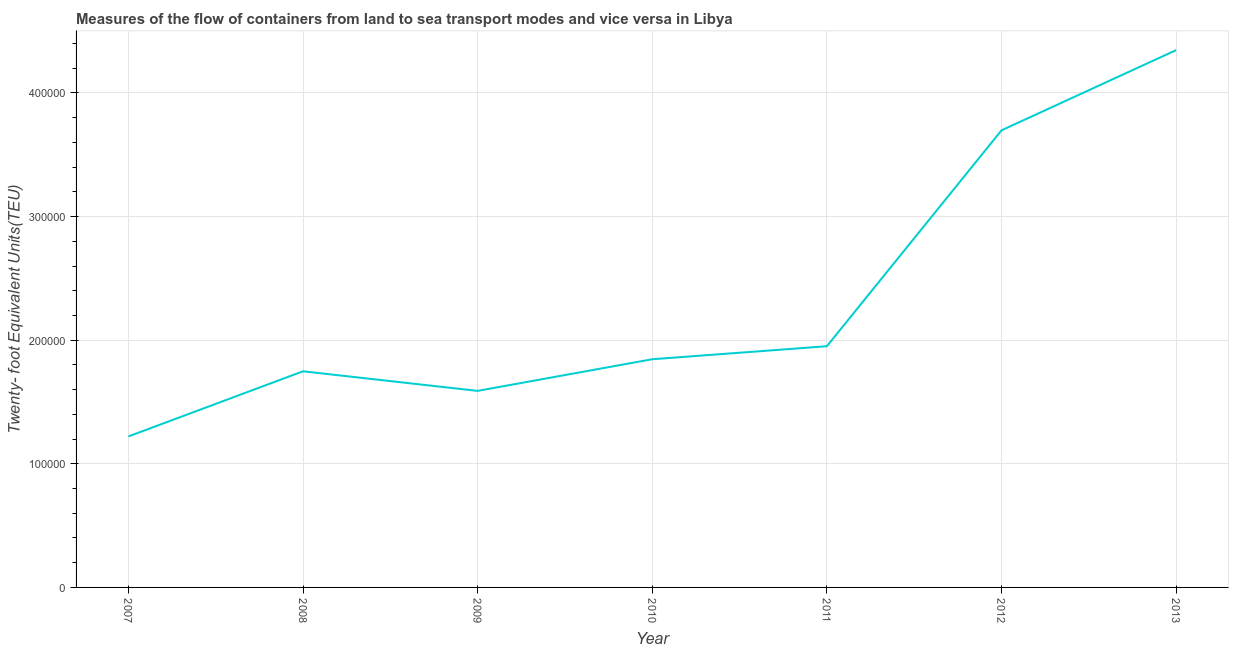What is the container port traffic in 2011?
Provide a short and direct response. 1.95e+05. Across all years, what is the maximum container port traffic?
Keep it short and to the point. 4.35e+05. Across all years, what is the minimum container port traffic?
Your response must be concise. 1.22e+05. In which year was the container port traffic minimum?
Provide a short and direct response. 2007. What is the sum of the container port traffic?
Offer a very short reply. 1.64e+06. What is the difference between the container port traffic in 2008 and 2013?
Make the answer very short. -2.60e+05. What is the average container port traffic per year?
Your answer should be compact. 2.34e+05. What is the median container port traffic?
Give a very brief answer. 1.85e+05. In how many years, is the container port traffic greater than 120000 TEU?
Give a very brief answer. 7. Do a majority of the years between 2009 and 2010 (inclusive) have container port traffic greater than 300000 TEU?
Ensure brevity in your answer.  No. What is the ratio of the container port traffic in 2008 to that in 2013?
Make the answer very short. 0.4. Is the container port traffic in 2008 less than that in 2010?
Offer a very short reply. Yes. Is the difference between the container port traffic in 2010 and 2012 greater than the difference between any two years?
Keep it short and to the point. No. What is the difference between the highest and the second highest container port traffic?
Offer a very short reply. 6.49e+04. What is the difference between the highest and the lowest container port traffic?
Your response must be concise. 3.12e+05. In how many years, is the container port traffic greater than the average container port traffic taken over all years?
Your response must be concise. 2. Does the container port traffic monotonically increase over the years?
Your answer should be compact. No. How many lines are there?
Offer a terse response. 1. What is the difference between two consecutive major ticks on the Y-axis?
Ensure brevity in your answer.  1.00e+05. Does the graph contain grids?
Make the answer very short. Yes. What is the title of the graph?
Offer a very short reply. Measures of the flow of containers from land to sea transport modes and vice versa in Libya. What is the label or title of the Y-axis?
Offer a very short reply. Twenty- foot Equivalent Units(TEU). What is the Twenty- foot Equivalent Units(TEU) of 2007?
Offer a terse response. 1.22e+05. What is the Twenty- foot Equivalent Units(TEU) in 2008?
Your response must be concise. 1.75e+05. What is the Twenty- foot Equivalent Units(TEU) of 2009?
Your response must be concise. 1.59e+05. What is the Twenty- foot Equivalent Units(TEU) in 2010?
Give a very brief answer. 1.85e+05. What is the Twenty- foot Equivalent Units(TEU) in 2011?
Ensure brevity in your answer.  1.95e+05. What is the Twenty- foot Equivalent Units(TEU) of 2012?
Make the answer very short. 3.70e+05. What is the Twenty- foot Equivalent Units(TEU) in 2013?
Give a very brief answer. 4.35e+05. What is the difference between the Twenty- foot Equivalent Units(TEU) in 2007 and 2008?
Your answer should be very brief. -5.27e+04. What is the difference between the Twenty- foot Equivalent Units(TEU) in 2007 and 2009?
Ensure brevity in your answer.  -3.69e+04. What is the difference between the Twenty- foot Equivalent Units(TEU) in 2007 and 2010?
Your answer should be very brief. -6.25e+04. What is the difference between the Twenty- foot Equivalent Units(TEU) in 2007 and 2011?
Offer a terse response. -7.30e+04. What is the difference between the Twenty- foot Equivalent Units(TEU) in 2007 and 2012?
Offer a very short reply. -2.48e+05. What is the difference between the Twenty- foot Equivalent Units(TEU) in 2007 and 2013?
Provide a short and direct response. -3.12e+05. What is the difference between the Twenty- foot Equivalent Units(TEU) in 2008 and 2009?
Ensure brevity in your answer.  1.58e+04. What is the difference between the Twenty- foot Equivalent Units(TEU) in 2008 and 2010?
Offer a very short reply. -9757.69. What is the difference between the Twenty- foot Equivalent Units(TEU) in 2008 and 2011?
Make the answer very short. -2.03e+04. What is the difference between the Twenty- foot Equivalent Units(TEU) in 2008 and 2012?
Your answer should be very brief. -1.95e+05. What is the difference between the Twenty- foot Equivalent Units(TEU) in 2008 and 2013?
Provide a short and direct response. -2.60e+05. What is the difference between the Twenty- foot Equivalent Units(TEU) in 2009 and 2010?
Give a very brief answer. -2.56e+04. What is the difference between the Twenty- foot Equivalent Units(TEU) in 2009 and 2011?
Offer a terse response. -3.61e+04. What is the difference between the Twenty- foot Equivalent Units(TEU) in 2009 and 2012?
Make the answer very short. -2.11e+05. What is the difference between the Twenty- foot Equivalent Units(TEU) in 2009 and 2013?
Make the answer very short. -2.76e+05. What is the difference between the Twenty- foot Equivalent Units(TEU) in 2010 and 2011?
Ensure brevity in your answer.  -1.05e+04. What is the difference between the Twenty- foot Equivalent Units(TEU) in 2010 and 2012?
Offer a very short reply. -1.85e+05. What is the difference between the Twenty- foot Equivalent Units(TEU) in 2010 and 2013?
Ensure brevity in your answer.  -2.50e+05. What is the difference between the Twenty- foot Equivalent Units(TEU) in 2011 and 2012?
Give a very brief answer. -1.75e+05. What is the difference between the Twenty- foot Equivalent Units(TEU) in 2011 and 2013?
Your response must be concise. -2.40e+05. What is the difference between the Twenty- foot Equivalent Units(TEU) in 2012 and 2013?
Provide a short and direct response. -6.49e+04. What is the ratio of the Twenty- foot Equivalent Units(TEU) in 2007 to that in 2008?
Provide a short and direct response. 0.7. What is the ratio of the Twenty- foot Equivalent Units(TEU) in 2007 to that in 2009?
Give a very brief answer. 0.77. What is the ratio of the Twenty- foot Equivalent Units(TEU) in 2007 to that in 2010?
Provide a succinct answer. 0.66. What is the ratio of the Twenty- foot Equivalent Units(TEU) in 2007 to that in 2011?
Keep it short and to the point. 0.63. What is the ratio of the Twenty- foot Equivalent Units(TEU) in 2007 to that in 2012?
Provide a succinct answer. 0.33. What is the ratio of the Twenty- foot Equivalent Units(TEU) in 2007 to that in 2013?
Offer a very short reply. 0.28. What is the ratio of the Twenty- foot Equivalent Units(TEU) in 2008 to that in 2009?
Provide a short and direct response. 1.1. What is the ratio of the Twenty- foot Equivalent Units(TEU) in 2008 to that in 2010?
Make the answer very short. 0.95. What is the ratio of the Twenty- foot Equivalent Units(TEU) in 2008 to that in 2011?
Keep it short and to the point. 0.9. What is the ratio of the Twenty- foot Equivalent Units(TEU) in 2008 to that in 2012?
Provide a short and direct response. 0.47. What is the ratio of the Twenty- foot Equivalent Units(TEU) in 2008 to that in 2013?
Your answer should be very brief. 0.4. What is the ratio of the Twenty- foot Equivalent Units(TEU) in 2009 to that in 2010?
Ensure brevity in your answer.  0.86. What is the ratio of the Twenty- foot Equivalent Units(TEU) in 2009 to that in 2011?
Give a very brief answer. 0.81. What is the ratio of the Twenty- foot Equivalent Units(TEU) in 2009 to that in 2012?
Your answer should be very brief. 0.43. What is the ratio of the Twenty- foot Equivalent Units(TEU) in 2009 to that in 2013?
Offer a very short reply. 0.37. What is the ratio of the Twenty- foot Equivalent Units(TEU) in 2010 to that in 2011?
Provide a succinct answer. 0.95. What is the ratio of the Twenty- foot Equivalent Units(TEU) in 2010 to that in 2012?
Provide a succinct answer. 0.5. What is the ratio of the Twenty- foot Equivalent Units(TEU) in 2010 to that in 2013?
Your answer should be compact. 0.42. What is the ratio of the Twenty- foot Equivalent Units(TEU) in 2011 to that in 2012?
Provide a succinct answer. 0.53. What is the ratio of the Twenty- foot Equivalent Units(TEU) in 2011 to that in 2013?
Provide a short and direct response. 0.45. What is the ratio of the Twenty- foot Equivalent Units(TEU) in 2012 to that in 2013?
Provide a short and direct response. 0.85. 